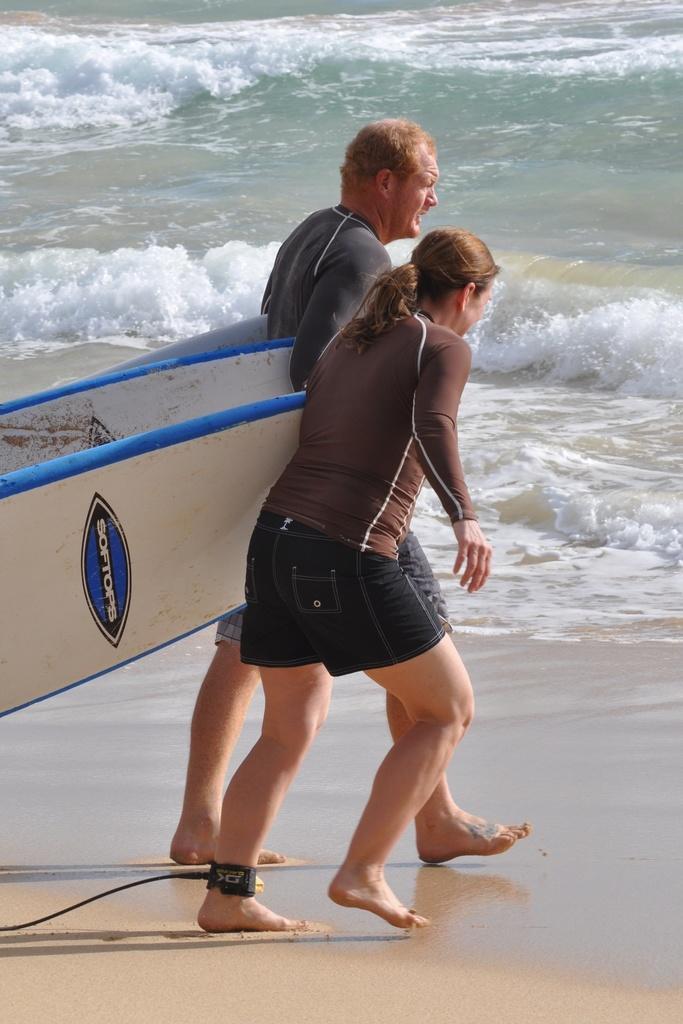Please provide a concise description of this image. This picture shows a man and woman walking into the water by holding surfboards in their hands 